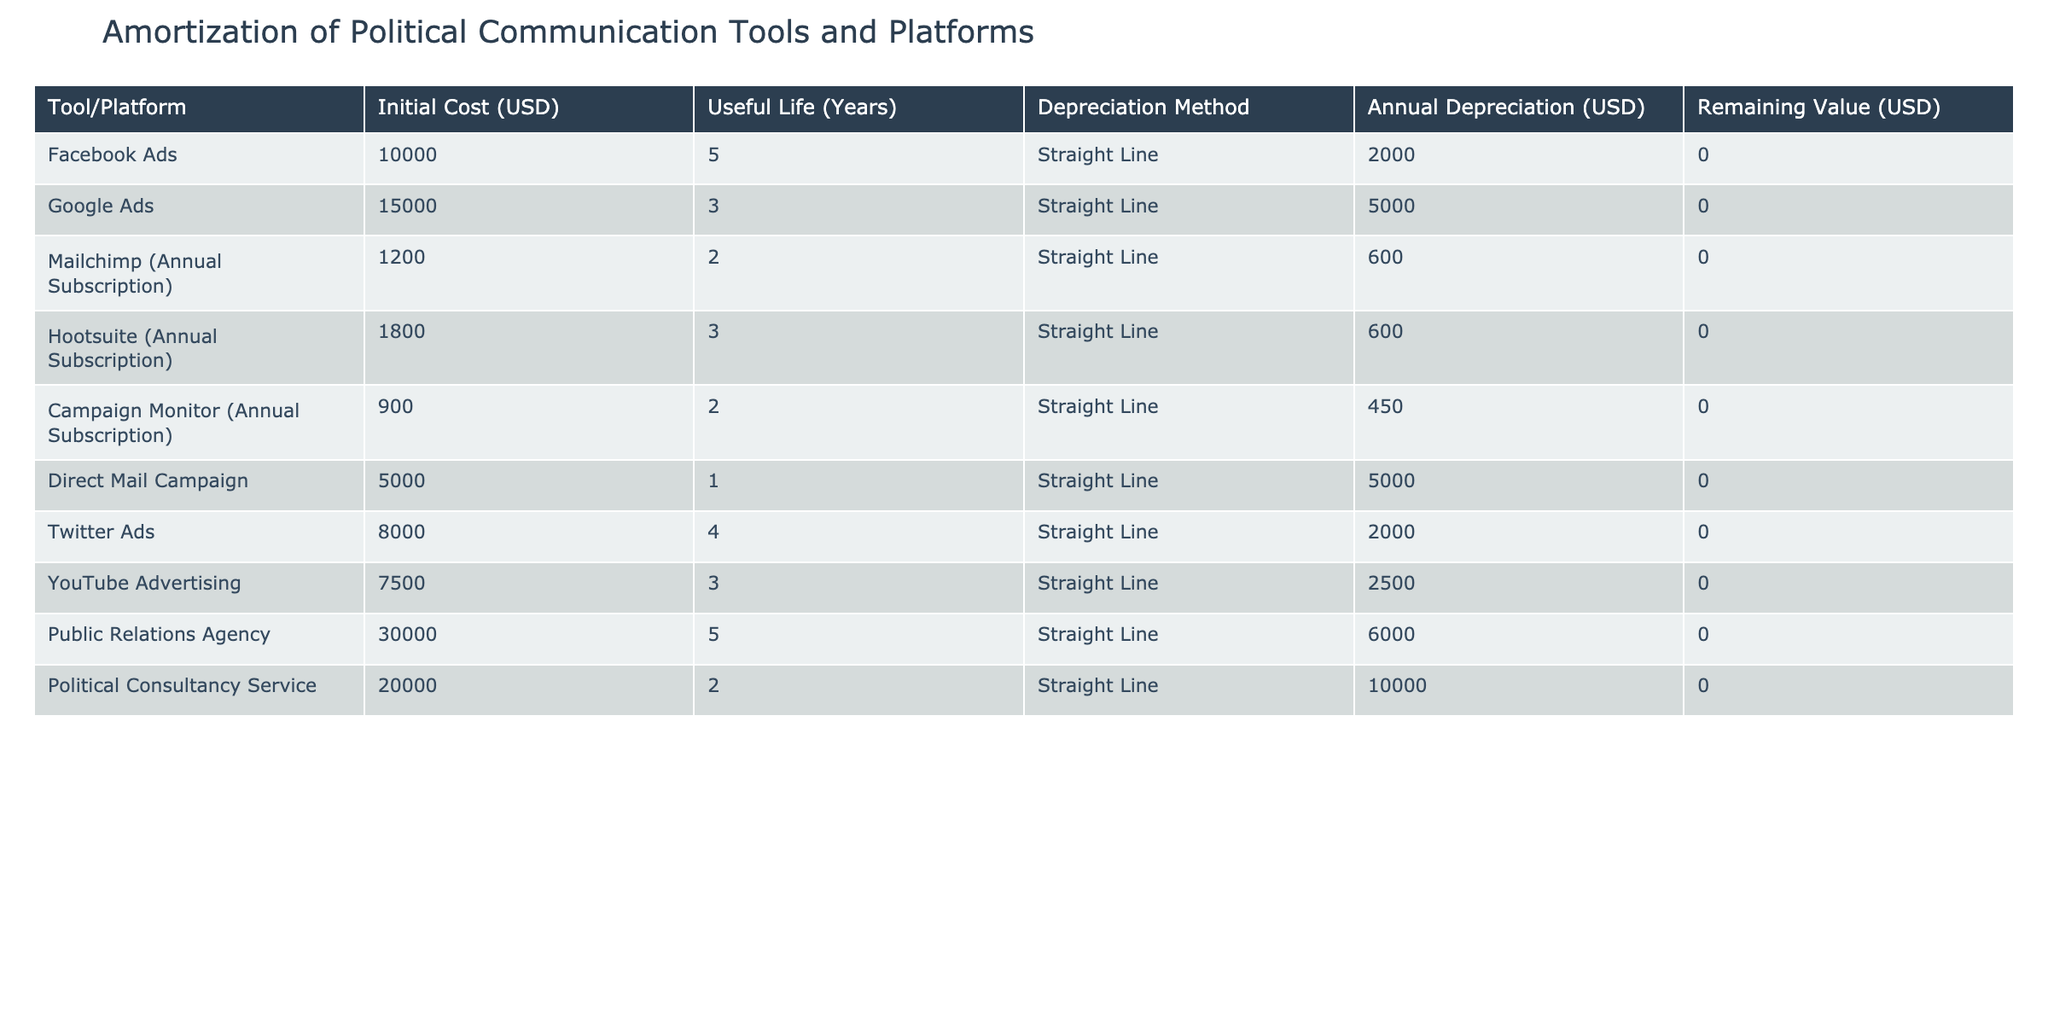What is the initial cost of Twitter Ads? The table states the initial cost for Twitter Ads is listed under the 'Initial Cost' column as 8000 USD.
Answer: 8000 USD How many years is the useful life of the Public Relations Agency tool? By reviewing the 'Useful Life' column for the Public Relations Agency row, it is indicated as 5 years.
Answer: 5 years What is the total annual depreciation for all the platforms combined? By summing the 'Annual Depreciation' column: 2000 (Facebook Ads) + 5000 (Google Ads) + 600 (Mailchimp) + 600 (Hootsuite) + 450 (Campaign Monitor) + 5000 (Direct Mail Campaign) + 2000 (Twitter Ads) + 2500 (YouTube Advertising) + 6000 (Public Relations Agency) + 10000 (Political Consultancy Service) = 40000 USD.
Answer: 40000 USD Is the remaining value of the Political Consultancy Service more than zero? The table indicates that the 'Remaining Value' for Political Consultancy Service is 0 USD, therefore the statement is false.
Answer: No Which political communication tool has the highest annual depreciation? Looking through the 'Annual Depreciation' column, Political Consultancy Service shows the highest depreciation at 10000 USD.
Answer: Political Consultancy Service What is the average initial cost of all the tools listed in the table? Calculating the average: Sum of initial costs = 10000 + 15000 + 1200 + 1800 + 900 + 5000 + 8000 + 7500 + 30000 + 20000 = 76800 USD. Number of tools = 10, so the average is 76800 / 10 = 7680 USD.
Answer: 7680 USD Does Direct Mail Campaign have a shorter useful life than Twitter Ads? Comparing the 'Useful Life' values, Direct Mail Campaign has 1 year, while Twitter Ads has 4 years, indicating that Direct Mail Campaign indeed has a shorter useful life.
Answer: Yes What is the combined initial cost of all subscription-based tools? The subscription costs are for Mailchimp (1200), Hootsuite (1800), Campaign Monitor (900). Adding these gives: 1200 + 1800 + 900 = 3900 USD.
Answer: 3900 USD What is the remaining value for all tools after their useful life ends? Since all tools listed show a remaining value of 0 USD due to full depreciation over their useful life, the answer is zero for all.
Answer: 0 USD 